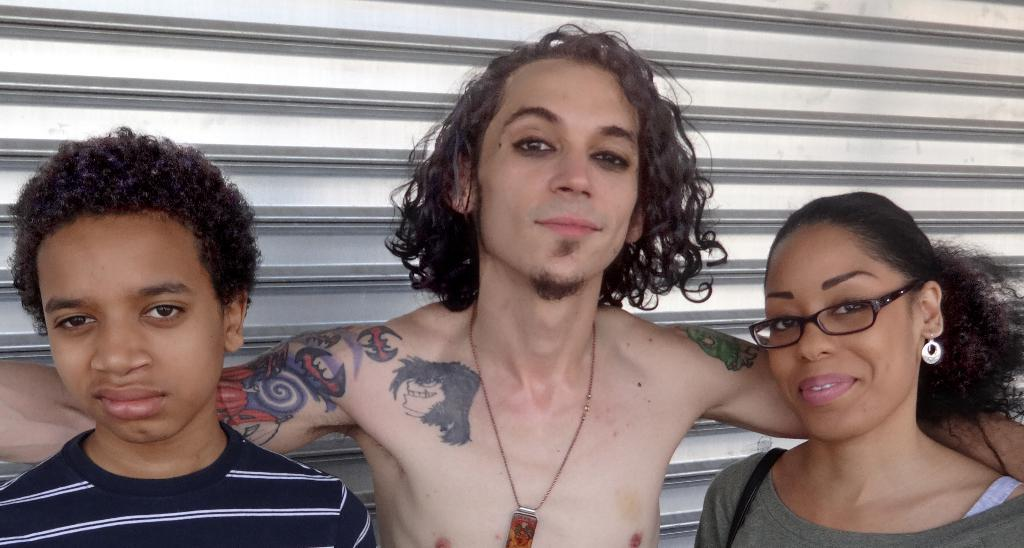How many people are present in the image? There are three persons in the image. Can you describe the position of one of the persons in the image? A lady is standing at the rightmost part of the image. What type of snail can be seen crawling on the lady's shoulder in the image? There is no snail present on the lady's shoulder in the image. What do you believe the lady is thinking about in the image? We cannot determine what the lady is thinking about in the image based on the provided facts. 